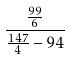<formula> <loc_0><loc_0><loc_500><loc_500>\frac { \frac { 9 9 } { 6 } } { \frac { 1 4 7 } { 4 } - 9 4 }</formula> 